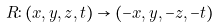<formula> <loc_0><loc_0><loc_500><loc_500>R \colon ( x , y , z , t ) \to ( - x , y , - z , - t )</formula> 